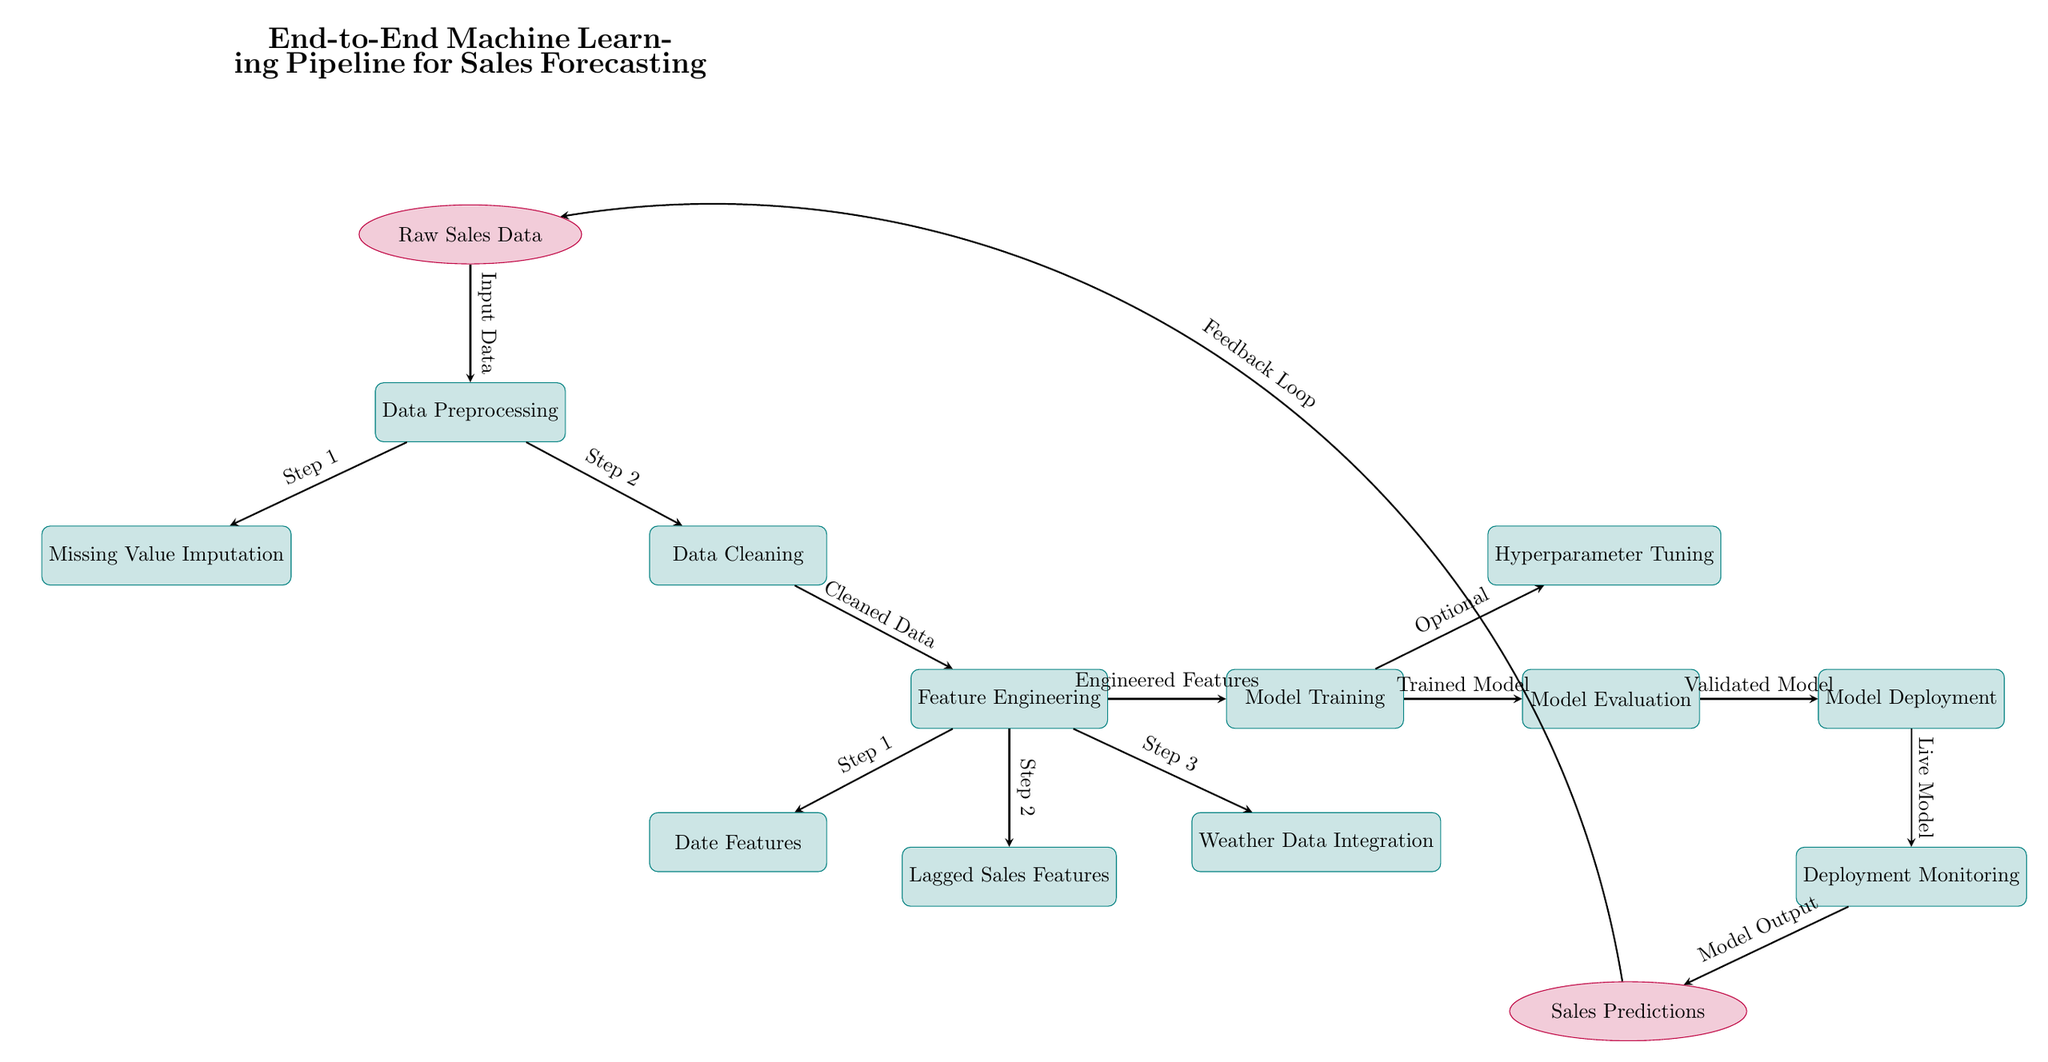What is the first step in the pipeline? The diagram indicates that the first step in the pipeline is "Data Preprocessing," which follows the "Raw Sales Data" node.
Answer: Data Preprocessing How many processes are involved after Data Preprocessing? After the "Data Preprocessing" step, there are three processes leading to "Feature Engineering": "Missing Value Imputation," "Data Cleaning," and subsequently "Feature Engineering." Hence, there are three processes.
Answer: Three What does the model output lead to? According to the diagram, the model output, labeled "Model Output," leads to "Sales Predictions," which indicates the output's purpose.
Answer: Sales Predictions What is the last process in the pipeline? The diagram shows that the last process in the pipeline is "Deployment Monitoring," which is the end of the modeling process flow.
Answer: Deployment Monitoring Which process is optional? The diagram specifies that "Hyperparameter Tuning" is an optional step following the "Model Training" process, indicated by the label "Optional."
Answer: Hyperparameter Tuning How many feature engineering steps are depicted in the diagram? The diagram outlines three distinct steps within the "Feature Engineering" process, which includes "Date Features," "Lagged Sales Features," and "Weather Data Integration."
Answer: Three What type of data is shown as feedback? The diagram indicates that "Sales Predictions" is the data shown as feedback, which loops back to "Raw Sales Data."
Answer: Sales Predictions What is the output of the "Model Evaluation"? "Model Evaluation" outputs a "Validated Model," which is a critical step in assessing the model's performance before deployment.
Answer: Validated Model 